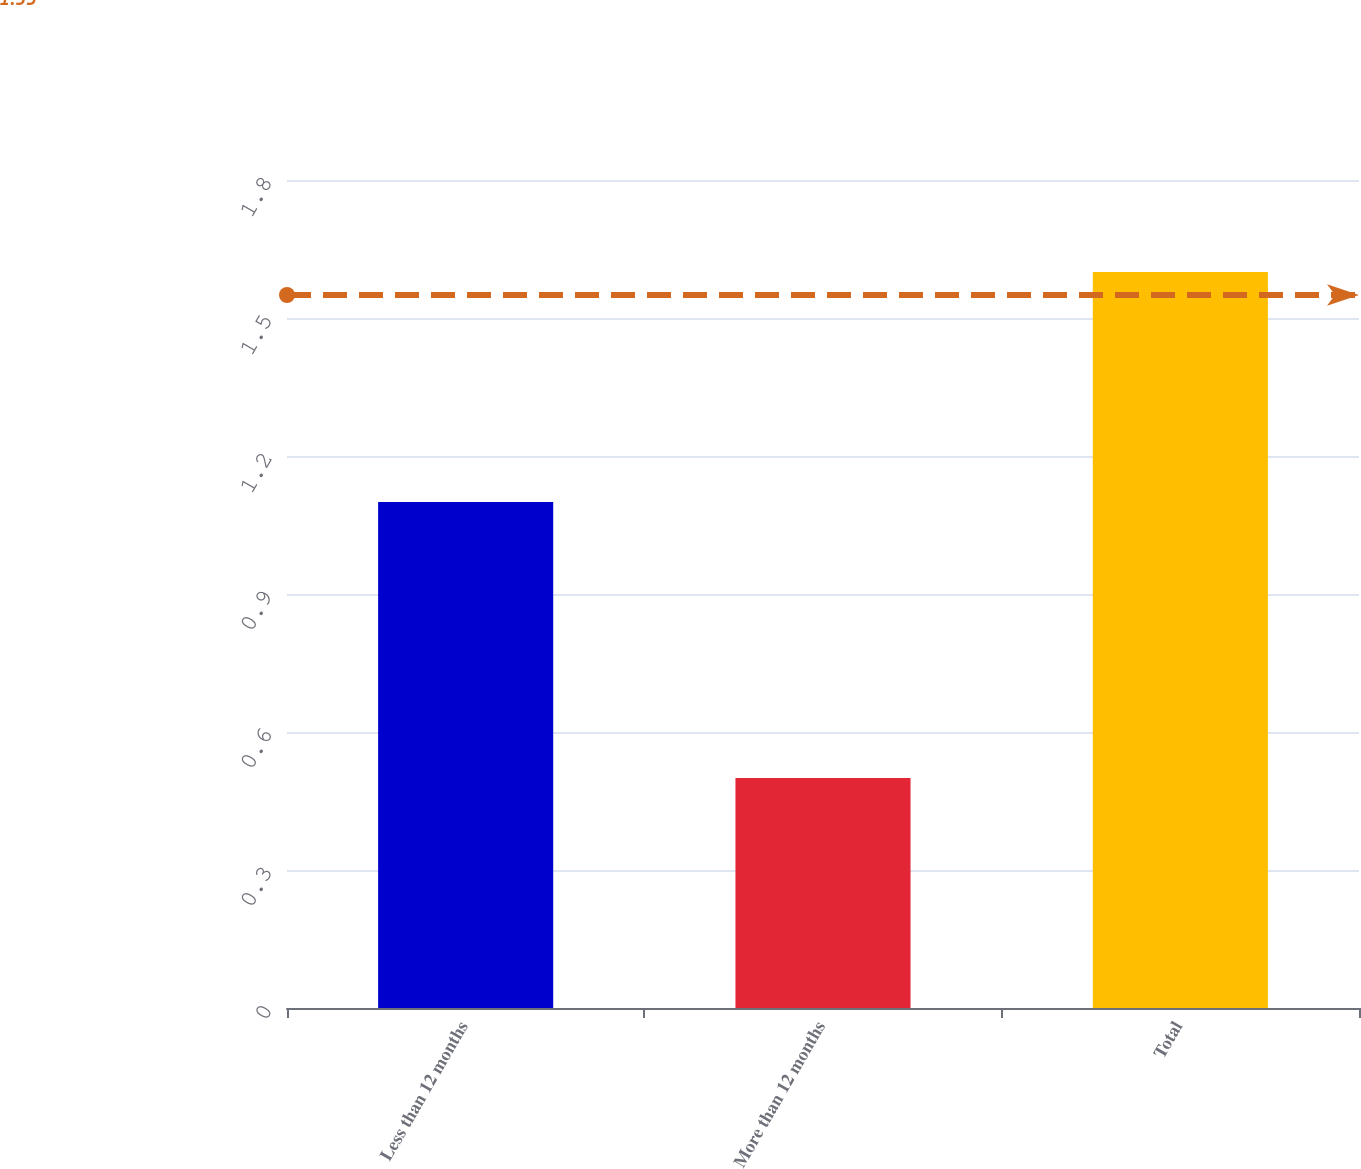Convert chart to OTSL. <chart><loc_0><loc_0><loc_500><loc_500><bar_chart><fcel>Less than 12 months<fcel>More than 12 months<fcel>Total<nl><fcel>1.1<fcel>0.5<fcel>1.6<nl></chart> 